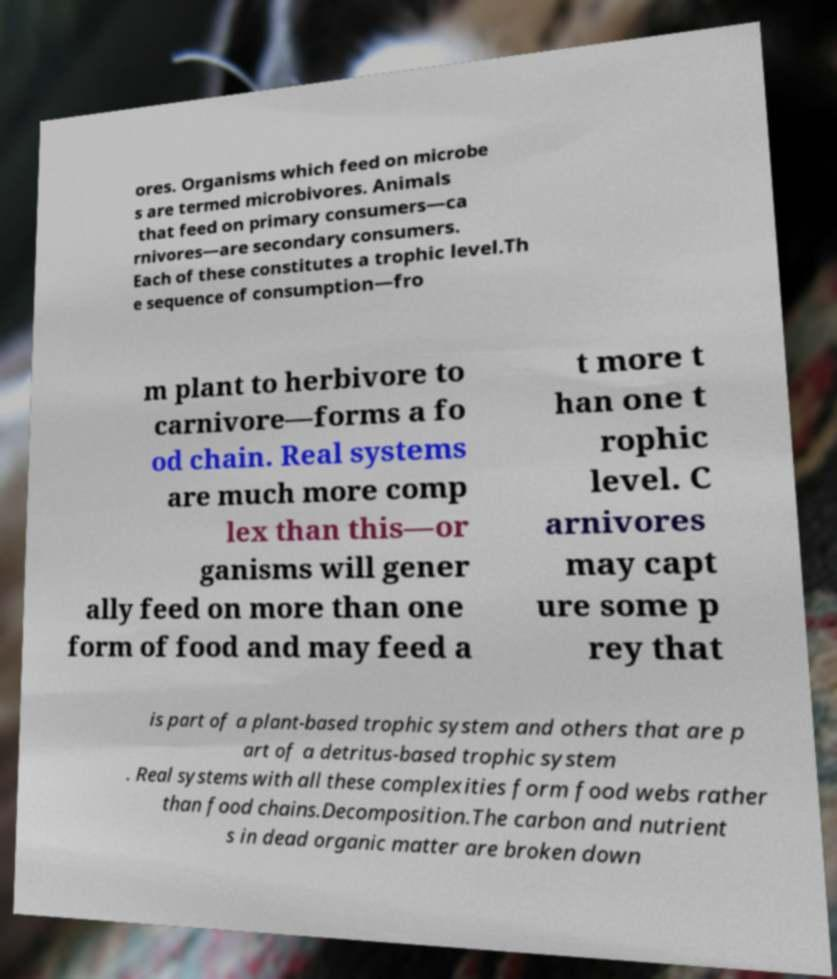Please identify and transcribe the text found in this image. ores. Organisms which feed on microbe s are termed microbivores. Animals that feed on primary consumers—ca rnivores—are secondary consumers. Each of these constitutes a trophic level.Th e sequence of consumption—fro m plant to herbivore to carnivore—forms a fo od chain. Real systems are much more comp lex than this—or ganisms will gener ally feed on more than one form of food and may feed a t more t han one t rophic level. C arnivores may capt ure some p rey that is part of a plant-based trophic system and others that are p art of a detritus-based trophic system . Real systems with all these complexities form food webs rather than food chains.Decomposition.The carbon and nutrient s in dead organic matter are broken down 